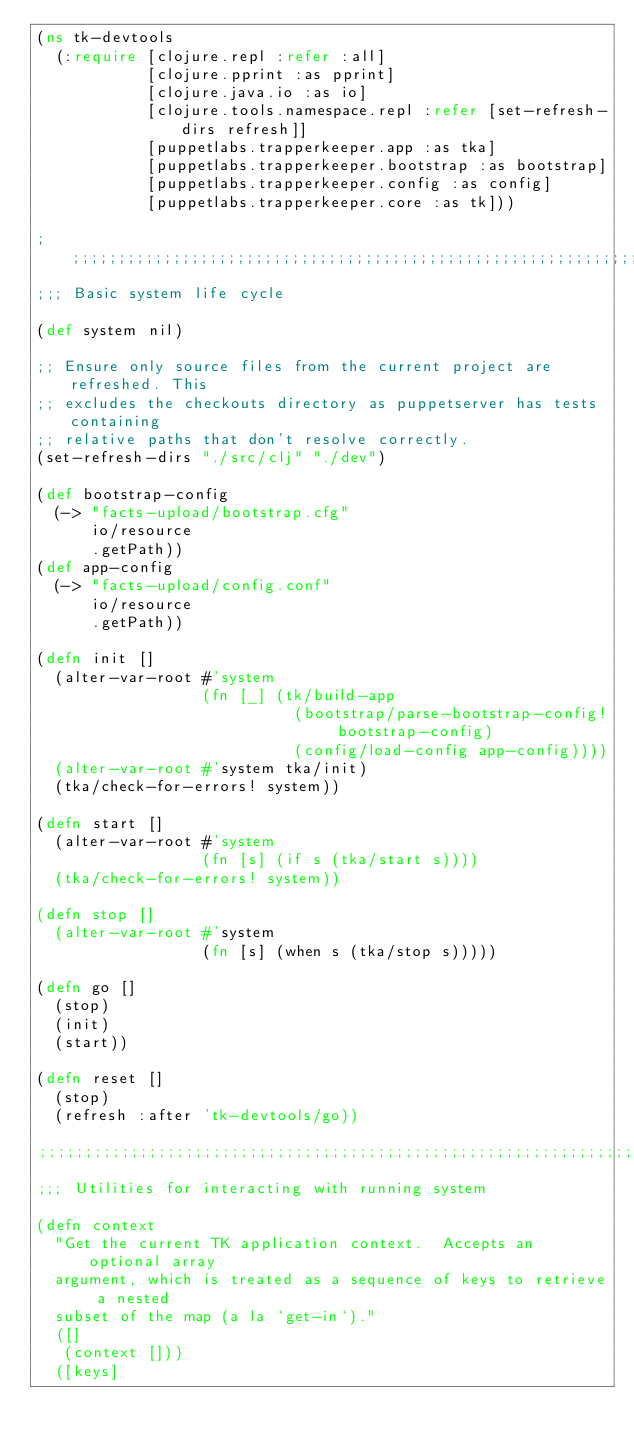Convert code to text. <code><loc_0><loc_0><loc_500><loc_500><_Clojure_>(ns tk-devtools
  (:require [clojure.repl :refer :all]
            [clojure.pprint :as pprint]
            [clojure.java.io :as io]
            [clojure.tools.namespace.repl :refer [set-refresh-dirs refresh]]
            [puppetlabs.trapperkeeper.app :as tka]
            [puppetlabs.trapperkeeper.bootstrap :as bootstrap]
            [puppetlabs.trapperkeeper.config :as config]
            [puppetlabs.trapperkeeper.core :as tk]))

;;;;;;;;;;;;;;;;;;;;;;;;;;;;;;;;;;;;;;;;;;;;;;;;;;;;;;;;;;;;;;;;;;;;;;;;;;;;;;;
;;; Basic system life cycle

(def system nil)

;; Ensure only source files from the current project are refreshed. This
;; excludes the checkouts directory as puppetserver has tests containing
;; relative paths that don't resolve correctly.
(set-refresh-dirs "./src/clj" "./dev")

(def bootstrap-config
  (-> "facts-upload/bootstrap.cfg"
      io/resource
      .getPath))
(def app-config
  (-> "facts-upload/config.conf"
      io/resource
      .getPath))

(defn init []
  (alter-var-root #'system
                  (fn [_] (tk/build-app
                            (bootstrap/parse-bootstrap-config! bootstrap-config)
                            (config/load-config app-config))))
  (alter-var-root #'system tka/init)
  (tka/check-for-errors! system))

(defn start []
  (alter-var-root #'system
                  (fn [s] (if s (tka/start s))))
  (tka/check-for-errors! system))

(defn stop []
  (alter-var-root #'system
                  (fn [s] (when s (tka/stop s)))))

(defn go []
  (stop)
  (init)
  (start))

(defn reset []
  (stop)
  (refresh :after 'tk-devtools/go))

;;;;;;;;;;;;;;;;;;;;;;;;;;;;;;;;;;;;;;;;;;;;;;;;;;;;;;;;;;;;;;;;;;;;;;;;;;;;;;;
;;; Utilities for interacting with running system

(defn context
  "Get the current TK application context.  Accepts an optional array
  argument, which is treated as a sequence of keys to retrieve a nested
  subset of the map (a la `get-in`)."
  ([]
   (context []))
  ([keys]</code> 